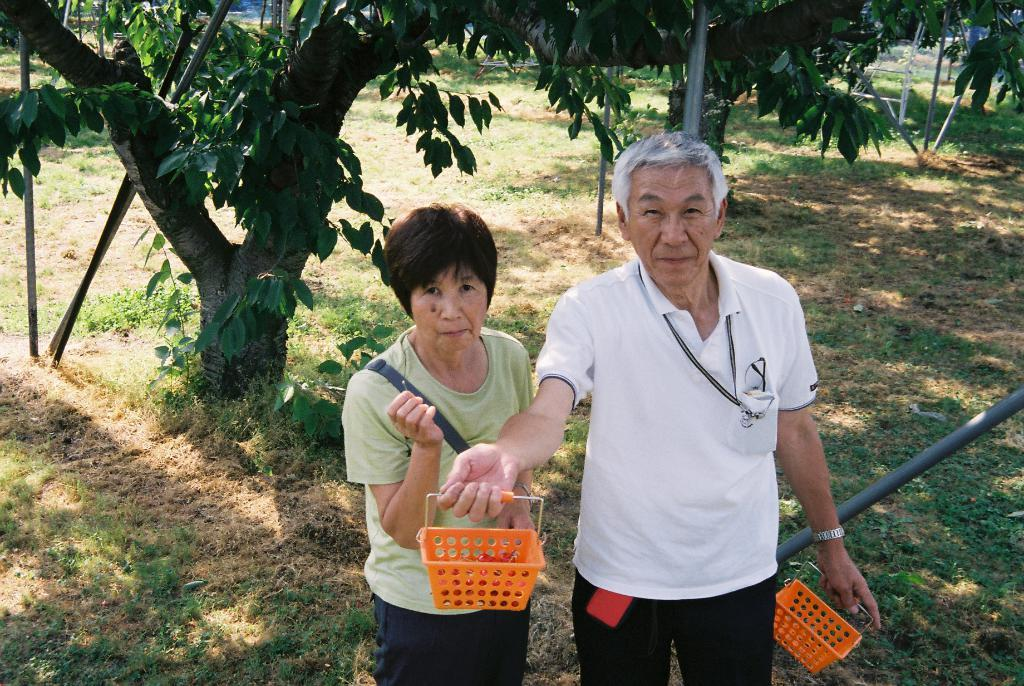How many people are present in the image? There are two people, a man and a woman, present in the image. What are the man and woman doing in the image? Both the man and woman are standing on the ground. What is the man holding in the image? The man is holding baskets. What type of terrain is visible in the image? There is grass visible in the image. What other objects can be seen in the image? There are poles and trees in the image. What type of chess piece is the woman holding in the image? There is no chess piece present in the image; the woman is not holding anything. 